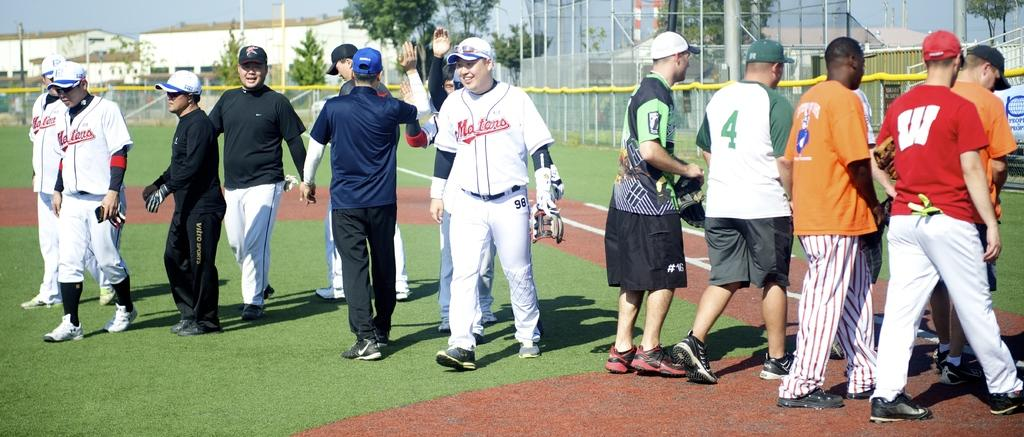Provide a one-sentence caption for the provided image. The Maters baseball team walking out onto the field as people in casual clothes walk off. 